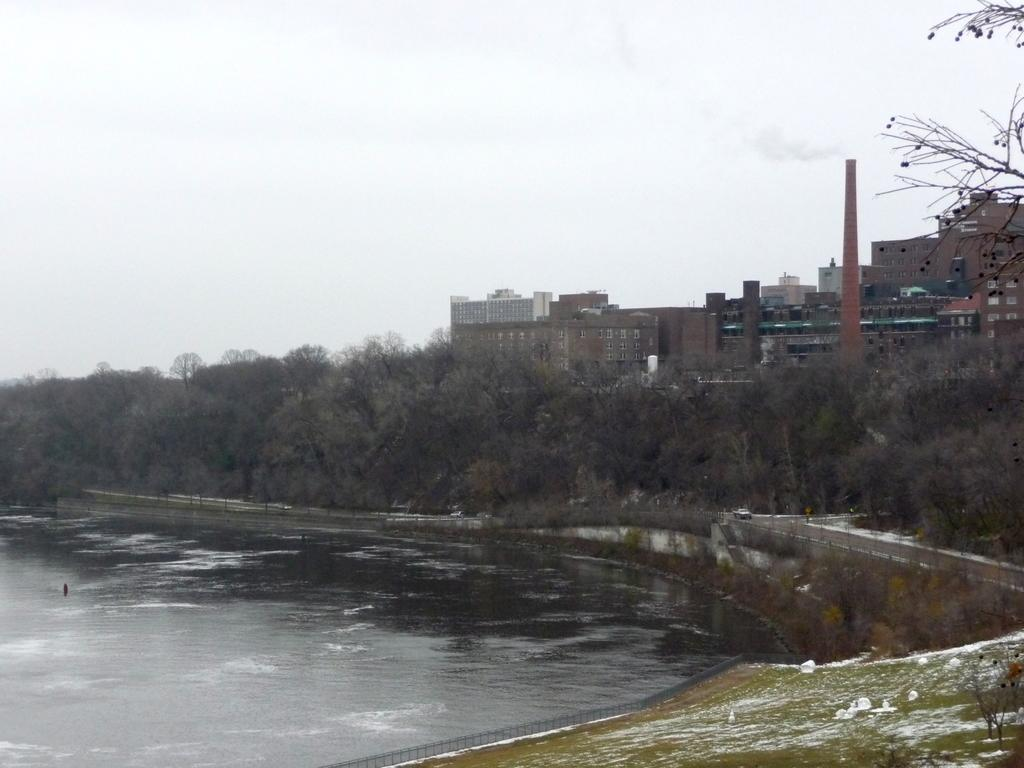What type of structures can be seen in the image? There are buildings in the image. What natural elements are present in the image? There are trees and water visible in the image. What type of barrier is located beside the water? There is fencing beside the water in the image. What is visible at the top of the image? The sky is visible at the top of the image. What can be observed in the sky? Clouds are present in the sky. Where is the quince located in the image? There is no quince present in the image. What type of thread is being used to create the fencing in the image? The image does not provide information about the type of thread used for the fencing. 